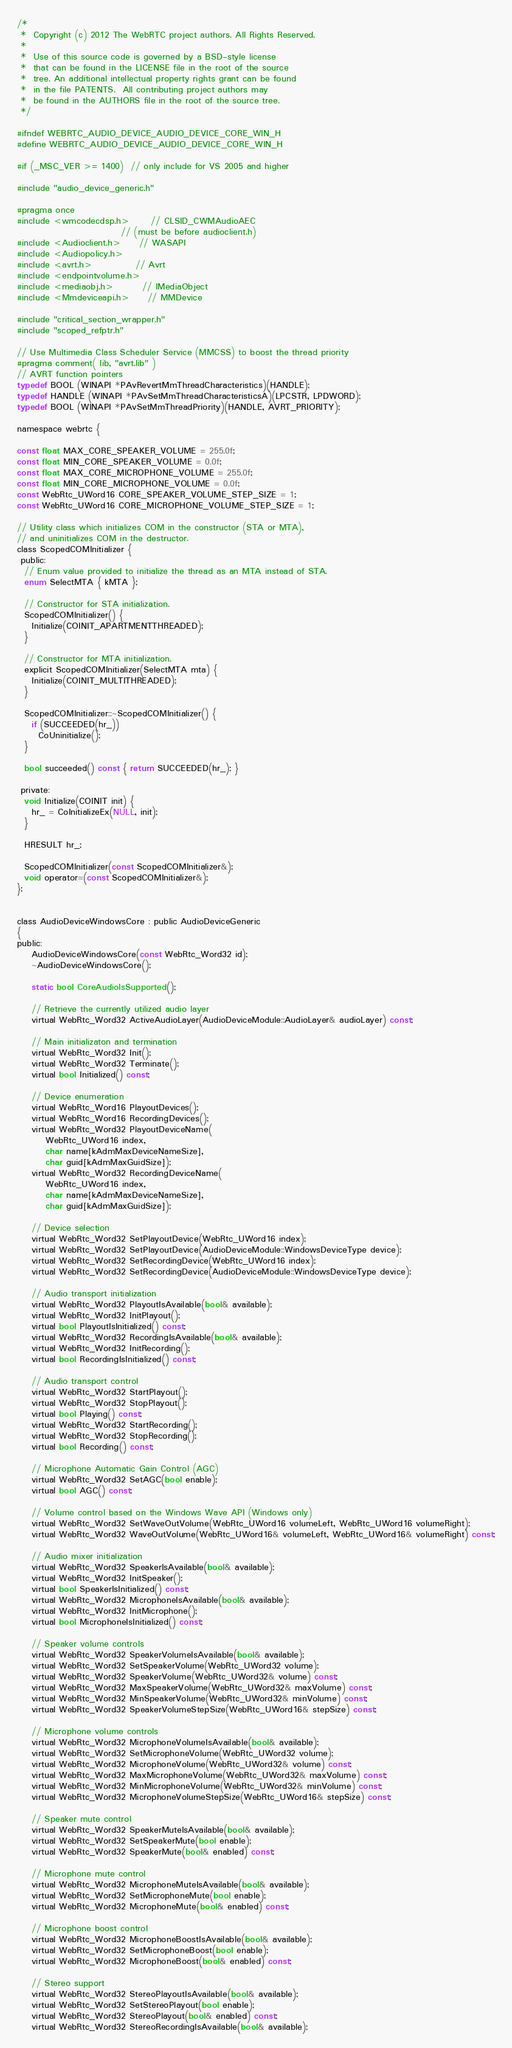<code> <loc_0><loc_0><loc_500><loc_500><_C_>/*
 *  Copyright (c) 2012 The WebRTC project authors. All Rights Reserved.
 *
 *  Use of this source code is governed by a BSD-style license
 *  that can be found in the LICENSE file in the root of the source
 *  tree. An additional intellectual property rights grant can be found
 *  in the file PATENTS.  All contributing project authors may
 *  be found in the AUTHORS file in the root of the source tree.
 */

#ifndef WEBRTC_AUDIO_DEVICE_AUDIO_DEVICE_CORE_WIN_H
#define WEBRTC_AUDIO_DEVICE_AUDIO_DEVICE_CORE_WIN_H

#if (_MSC_VER >= 1400)  // only include for VS 2005 and higher

#include "audio_device_generic.h"

#pragma once
#include <wmcodecdsp.h>      // CLSID_CWMAudioAEC
                             // (must be before audioclient.h)
#include <Audioclient.h>     // WASAPI
#include <Audiopolicy.h>
#include <avrt.h>            // Avrt
#include <endpointvolume.h>
#include <mediaobj.h>        // IMediaObject
#include <Mmdeviceapi.h>     // MMDevice

#include "critical_section_wrapper.h"
#include "scoped_refptr.h"

// Use Multimedia Class Scheduler Service (MMCSS) to boost the thread priority
#pragma comment( lib, "avrt.lib" )
// AVRT function pointers
typedef BOOL (WINAPI *PAvRevertMmThreadCharacteristics)(HANDLE);
typedef HANDLE (WINAPI *PAvSetMmThreadCharacteristicsA)(LPCSTR, LPDWORD);
typedef BOOL (WINAPI *PAvSetMmThreadPriority)(HANDLE, AVRT_PRIORITY);

namespace webrtc {

const float MAX_CORE_SPEAKER_VOLUME = 255.0f;
const float MIN_CORE_SPEAKER_VOLUME = 0.0f;
const float MAX_CORE_MICROPHONE_VOLUME = 255.0f;
const float MIN_CORE_MICROPHONE_VOLUME = 0.0f;
const WebRtc_UWord16 CORE_SPEAKER_VOLUME_STEP_SIZE = 1;
const WebRtc_UWord16 CORE_MICROPHONE_VOLUME_STEP_SIZE = 1;

// Utility class which initializes COM in the constructor (STA or MTA),
// and uninitializes COM in the destructor.
class ScopedCOMInitializer {
 public:
  // Enum value provided to initialize the thread as an MTA instead of STA.
  enum SelectMTA { kMTA };

  // Constructor for STA initialization.
  ScopedCOMInitializer() {
    Initialize(COINIT_APARTMENTTHREADED);
  }

  // Constructor for MTA initialization.
  explicit ScopedCOMInitializer(SelectMTA mta) {
    Initialize(COINIT_MULTITHREADED);
  }

  ScopedCOMInitializer::~ScopedCOMInitializer() {
    if (SUCCEEDED(hr_))
      CoUninitialize();
  }

  bool succeeded() const { return SUCCEEDED(hr_); }
 
 private:
  void Initialize(COINIT init) {
    hr_ = CoInitializeEx(NULL, init);
  }

  HRESULT hr_;

  ScopedCOMInitializer(const ScopedCOMInitializer&);
  void operator=(const ScopedCOMInitializer&);
};


class AudioDeviceWindowsCore : public AudioDeviceGeneric
{
public:
    AudioDeviceWindowsCore(const WebRtc_Word32 id);
    ~AudioDeviceWindowsCore();

    static bool CoreAudioIsSupported();

    // Retrieve the currently utilized audio layer
    virtual WebRtc_Word32 ActiveAudioLayer(AudioDeviceModule::AudioLayer& audioLayer) const;

    // Main initializaton and termination
    virtual WebRtc_Word32 Init();
    virtual WebRtc_Word32 Terminate();
    virtual bool Initialized() const;

    // Device enumeration
    virtual WebRtc_Word16 PlayoutDevices();
    virtual WebRtc_Word16 RecordingDevices();
    virtual WebRtc_Word32 PlayoutDeviceName(
        WebRtc_UWord16 index,
        char name[kAdmMaxDeviceNameSize],
        char guid[kAdmMaxGuidSize]);
    virtual WebRtc_Word32 RecordingDeviceName(
        WebRtc_UWord16 index,
        char name[kAdmMaxDeviceNameSize],
        char guid[kAdmMaxGuidSize]);

    // Device selection
    virtual WebRtc_Word32 SetPlayoutDevice(WebRtc_UWord16 index);
    virtual WebRtc_Word32 SetPlayoutDevice(AudioDeviceModule::WindowsDeviceType device);
    virtual WebRtc_Word32 SetRecordingDevice(WebRtc_UWord16 index);
    virtual WebRtc_Word32 SetRecordingDevice(AudioDeviceModule::WindowsDeviceType device);

    // Audio transport initialization
    virtual WebRtc_Word32 PlayoutIsAvailable(bool& available);
    virtual WebRtc_Word32 InitPlayout();
    virtual bool PlayoutIsInitialized() const;
    virtual WebRtc_Word32 RecordingIsAvailable(bool& available);
    virtual WebRtc_Word32 InitRecording();
    virtual bool RecordingIsInitialized() const;

    // Audio transport control
    virtual WebRtc_Word32 StartPlayout();
    virtual WebRtc_Word32 StopPlayout();
    virtual bool Playing() const;
    virtual WebRtc_Word32 StartRecording();
    virtual WebRtc_Word32 StopRecording();
    virtual bool Recording() const;

    // Microphone Automatic Gain Control (AGC)
    virtual WebRtc_Word32 SetAGC(bool enable);
    virtual bool AGC() const;

    // Volume control based on the Windows Wave API (Windows only)
    virtual WebRtc_Word32 SetWaveOutVolume(WebRtc_UWord16 volumeLeft, WebRtc_UWord16 volumeRight);
    virtual WebRtc_Word32 WaveOutVolume(WebRtc_UWord16& volumeLeft, WebRtc_UWord16& volumeRight) const;

    // Audio mixer initialization
    virtual WebRtc_Word32 SpeakerIsAvailable(bool& available);
    virtual WebRtc_Word32 InitSpeaker();
    virtual bool SpeakerIsInitialized() const;
    virtual WebRtc_Word32 MicrophoneIsAvailable(bool& available);
    virtual WebRtc_Word32 InitMicrophone();
    virtual bool MicrophoneIsInitialized() const;

    // Speaker volume controls
    virtual WebRtc_Word32 SpeakerVolumeIsAvailable(bool& available);
    virtual WebRtc_Word32 SetSpeakerVolume(WebRtc_UWord32 volume);
    virtual WebRtc_Word32 SpeakerVolume(WebRtc_UWord32& volume) const;
    virtual WebRtc_Word32 MaxSpeakerVolume(WebRtc_UWord32& maxVolume) const;
    virtual WebRtc_Word32 MinSpeakerVolume(WebRtc_UWord32& minVolume) const;
    virtual WebRtc_Word32 SpeakerVolumeStepSize(WebRtc_UWord16& stepSize) const;

    // Microphone volume controls
    virtual WebRtc_Word32 MicrophoneVolumeIsAvailable(bool& available);
    virtual WebRtc_Word32 SetMicrophoneVolume(WebRtc_UWord32 volume);
    virtual WebRtc_Word32 MicrophoneVolume(WebRtc_UWord32& volume) const;
    virtual WebRtc_Word32 MaxMicrophoneVolume(WebRtc_UWord32& maxVolume) const;
    virtual WebRtc_Word32 MinMicrophoneVolume(WebRtc_UWord32& minVolume) const;
    virtual WebRtc_Word32 MicrophoneVolumeStepSize(WebRtc_UWord16& stepSize) const;

    // Speaker mute control
    virtual WebRtc_Word32 SpeakerMuteIsAvailable(bool& available);
    virtual WebRtc_Word32 SetSpeakerMute(bool enable);
    virtual WebRtc_Word32 SpeakerMute(bool& enabled) const;

    // Microphone mute control
    virtual WebRtc_Word32 MicrophoneMuteIsAvailable(bool& available);
    virtual WebRtc_Word32 SetMicrophoneMute(bool enable);
    virtual WebRtc_Word32 MicrophoneMute(bool& enabled) const;

    // Microphone boost control
    virtual WebRtc_Word32 MicrophoneBoostIsAvailable(bool& available);
    virtual WebRtc_Word32 SetMicrophoneBoost(bool enable);
    virtual WebRtc_Word32 MicrophoneBoost(bool& enabled) const;

    // Stereo support
    virtual WebRtc_Word32 StereoPlayoutIsAvailable(bool& available);
    virtual WebRtc_Word32 SetStereoPlayout(bool enable);
    virtual WebRtc_Word32 StereoPlayout(bool& enabled) const;
    virtual WebRtc_Word32 StereoRecordingIsAvailable(bool& available);</code> 